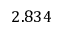Convert formula to latex. <formula><loc_0><loc_0><loc_500><loc_500>2 . 8 3 4</formula> 